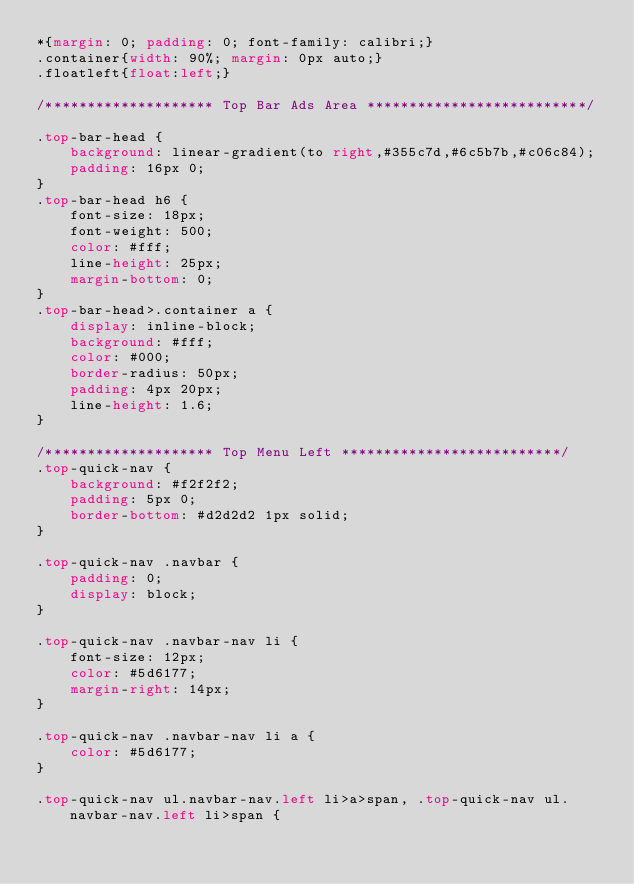<code> <loc_0><loc_0><loc_500><loc_500><_CSS_>*{margin: 0; padding: 0; font-family: calibri;}
.container{width: 90%; margin: 0px auto;}
.floatleft{float:left;}

/******************** Top Bar Ads Area **************************/

.top-bar-head {
    background: linear-gradient(to right,#355c7d,#6c5b7b,#c06c84);
    padding: 16px 0;
}
.top-bar-head h6 {
    font-size: 18px;
    font-weight: 500;
    color: #fff;
    line-height: 25px;
    margin-bottom: 0;
}
.top-bar-head>.container a {
    display: inline-block;
    background: #fff;
    color: #000;
    border-radius: 50px;
    padding: 4px 20px;
    line-height: 1.6;
}

/******************** Top Menu Left **************************/
.top-quick-nav {
    background: #f2f2f2;
    padding: 5px 0;
    border-bottom: #d2d2d2 1px solid;
}

.top-quick-nav .navbar {
    padding: 0;
    display: block;
}

.top-quick-nav .navbar-nav li {
    font-size: 12px;
    color: #5d6177;
    margin-right: 14px;
}

.top-quick-nav .navbar-nav li a {
    color: #5d6177;
}

.top-quick-nav ul.navbar-nav.left li>a>span, .top-quick-nav ul.navbar-nav.left li>span {</code> 